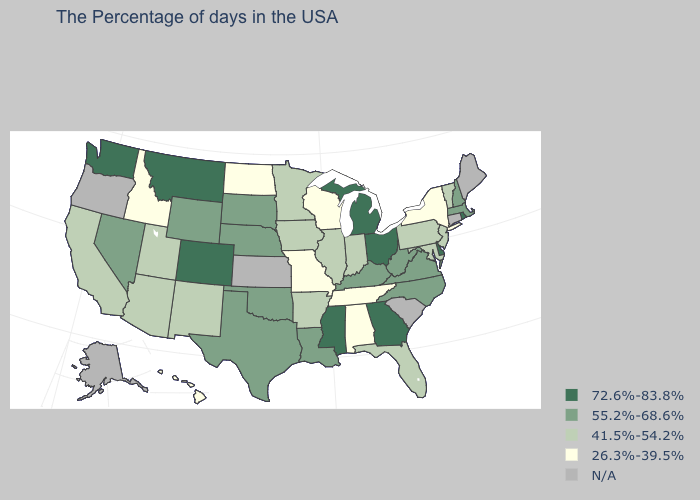How many symbols are there in the legend?
Write a very short answer. 5. How many symbols are there in the legend?
Quick response, please. 5. Which states have the highest value in the USA?
Short answer required. Rhode Island, Delaware, Ohio, Georgia, Michigan, Mississippi, Colorado, Montana, Washington. What is the value of Oregon?
Keep it brief. N/A. Does Oklahoma have the highest value in the South?
Concise answer only. No. What is the value of New Jersey?
Keep it brief. 41.5%-54.2%. What is the value of Georgia?
Give a very brief answer. 72.6%-83.8%. What is the lowest value in the Northeast?
Concise answer only. 26.3%-39.5%. Is the legend a continuous bar?
Concise answer only. No. Does the map have missing data?
Concise answer only. Yes. What is the lowest value in states that border New Hampshire?
Concise answer only. 41.5%-54.2%. Name the states that have a value in the range 26.3%-39.5%?
Keep it brief. New York, Alabama, Tennessee, Wisconsin, Missouri, North Dakota, Idaho, Hawaii. What is the value of Massachusetts?
Give a very brief answer. 55.2%-68.6%. 